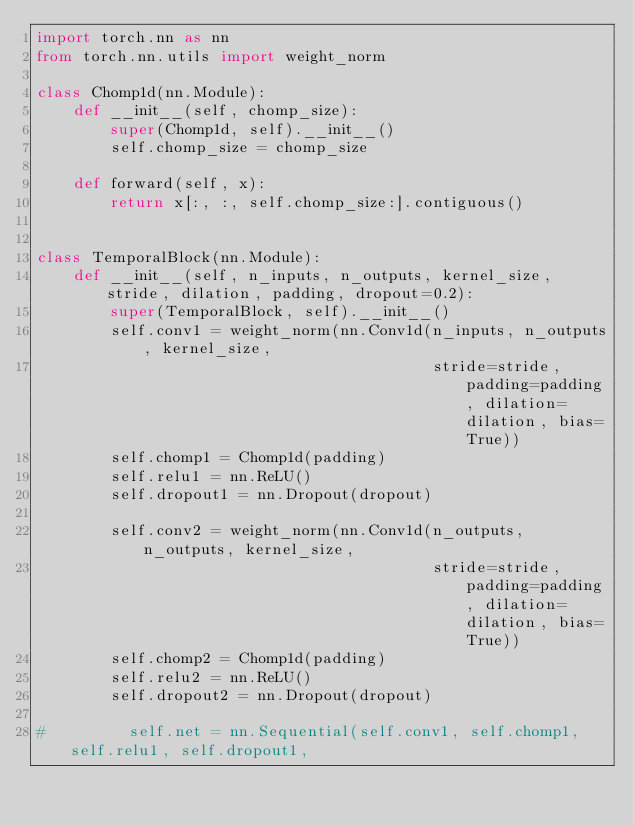Convert code to text. <code><loc_0><loc_0><loc_500><loc_500><_Python_>import torch.nn as nn
from torch.nn.utils import weight_norm

class Chomp1d(nn.Module):
    def __init__(self, chomp_size):
        super(Chomp1d, self).__init__()
        self.chomp_size = chomp_size

    def forward(self, x):
        return x[:, :, self.chomp_size:].contiguous()


class TemporalBlock(nn.Module):
    def __init__(self, n_inputs, n_outputs, kernel_size, stride, dilation, padding, dropout=0.2):
        super(TemporalBlock, self).__init__()
        self.conv1 = weight_norm(nn.Conv1d(n_inputs, n_outputs, kernel_size,
                                           stride=stride, padding=padding, dilation=dilation, bias=True))
        self.chomp1 = Chomp1d(padding)
        self.relu1 = nn.ReLU()
        self.dropout1 = nn.Dropout(dropout)

        self.conv2 = weight_norm(nn.Conv1d(n_outputs, n_outputs, kernel_size,
                                           stride=stride, padding=padding, dilation=dilation, bias=True))
        self.chomp2 = Chomp1d(padding)
        self.relu2 = nn.ReLU()
        self.dropout2 = nn.Dropout(dropout)

#         self.net = nn.Sequential(self.conv1, self.chomp1, self.relu1, self.dropout1,</code> 